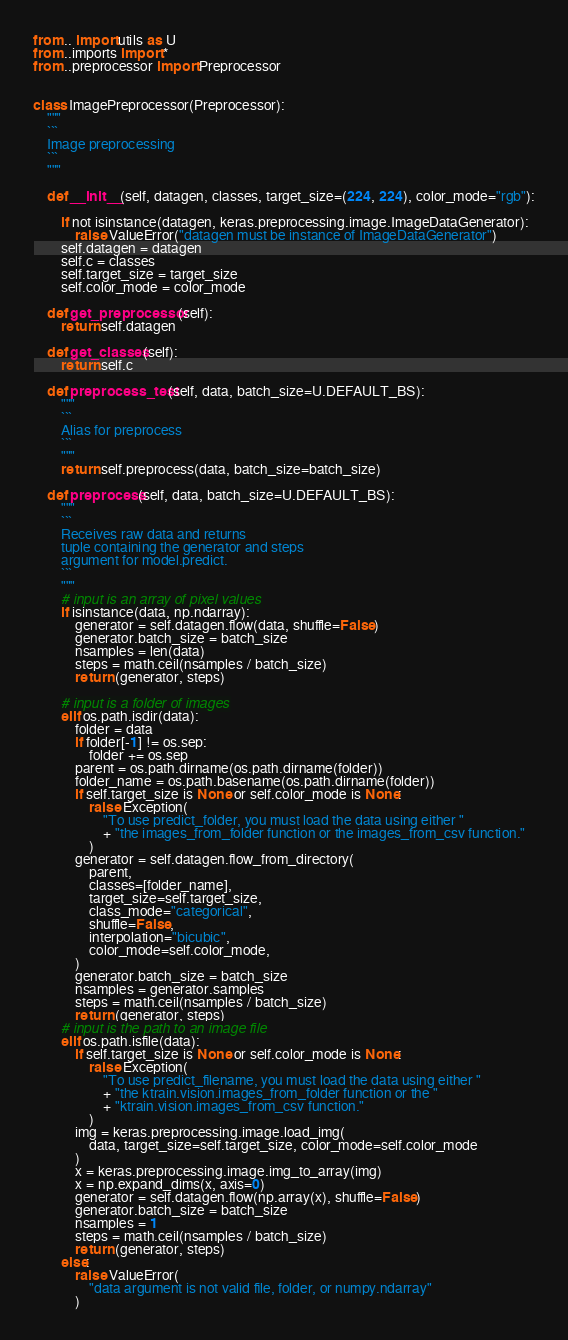<code> <loc_0><loc_0><loc_500><loc_500><_Python_>from .. import utils as U
from ..imports import *
from ..preprocessor import Preprocessor


class ImagePreprocessor(Preprocessor):
    """
    ```
    Image preprocessing
    ```
    """

    def __init__(self, datagen, classes, target_size=(224, 224), color_mode="rgb"):

        if not isinstance(datagen, keras.preprocessing.image.ImageDataGenerator):
            raise ValueError("datagen must be instance of ImageDataGenerator")
        self.datagen = datagen
        self.c = classes
        self.target_size = target_size
        self.color_mode = color_mode

    def get_preprocessor(self):
        return self.datagen

    def get_classes(self):
        return self.c

    def preprocess_test(self, data, batch_size=U.DEFAULT_BS):
        """
        ```
        Alias for preprocess
        ```
        """
        return self.preprocess(data, batch_size=batch_size)

    def preprocess(self, data, batch_size=U.DEFAULT_BS):
        """
        ```
        Receives raw data and returns
        tuple containing the generator and steps
        argument for model.predict.
        ```
        """
        # input is an array of pixel values
        if isinstance(data, np.ndarray):
            generator = self.datagen.flow(data, shuffle=False)
            generator.batch_size = batch_size
            nsamples = len(data)
            steps = math.ceil(nsamples / batch_size)
            return (generator, steps)

        # input is a folder of images
        elif os.path.isdir(data):
            folder = data
            if folder[-1] != os.sep:
                folder += os.sep
            parent = os.path.dirname(os.path.dirname(folder))
            folder_name = os.path.basename(os.path.dirname(folder))
            if self.target_size is None or self.color_mode is None:
                raise Exception(
                    "To use predict_folder, you must load the data using either "
                    + "the images_from_folder function or the images_from_csv function."
                )
            generator = self.datagen.flow_from_directory(
                parent,
                classes=[folder_name],
                target_size=self.target_size,
                class_mode="categorical",
                shuffle=False,
                interpolation="bicubic",
                color_mode=self.color_mode,
            )
            generator.batch_size = batch_size
            nsamples = generator.samples
            steps = math.ceil(nsamples / batch_size)
            return (generator, steps)
        # input is the path to an image file
        elif os.path.isfile(data):
            if self.target_size is None or self.color_mode is None:
                raise Exception(
                    "To use predict_filename, you must load the data using either "
                    + "the ktrain.vision.images_from_folder function or the "
                    + "ktrain.vision.images_from_csv function."
                )
            img = keras.preprocessing.image.load_img(
                data, target_size=self.target_size, color_mode=self.color_mode
            )
            x = keras.preprocessing.image.img_to_array(img)
            x = np.expand_dims(x, axis=0)
            generator = self.datagen.flow(np.array(x), shuffle=False)
            generator.batch_size = batch_size
            nsamples = 1
            steps = math.ceil(nsamples / batch_size)
            return (generator, steps)
        else:
            raise ValueError(
                "data argument is not valid file, folder, or numpy.ndarray"
            )
</code> 